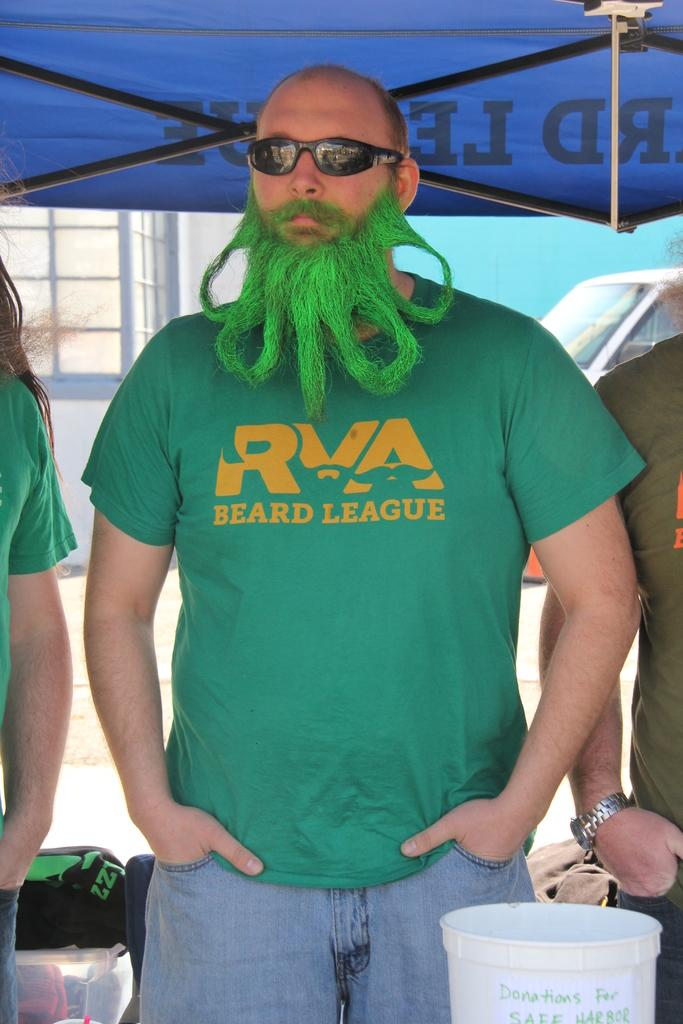<image>
Give a short and clear explanation of the subsequent image. A man with a green beard and a green shirt that reads, "RVA Beard League". 